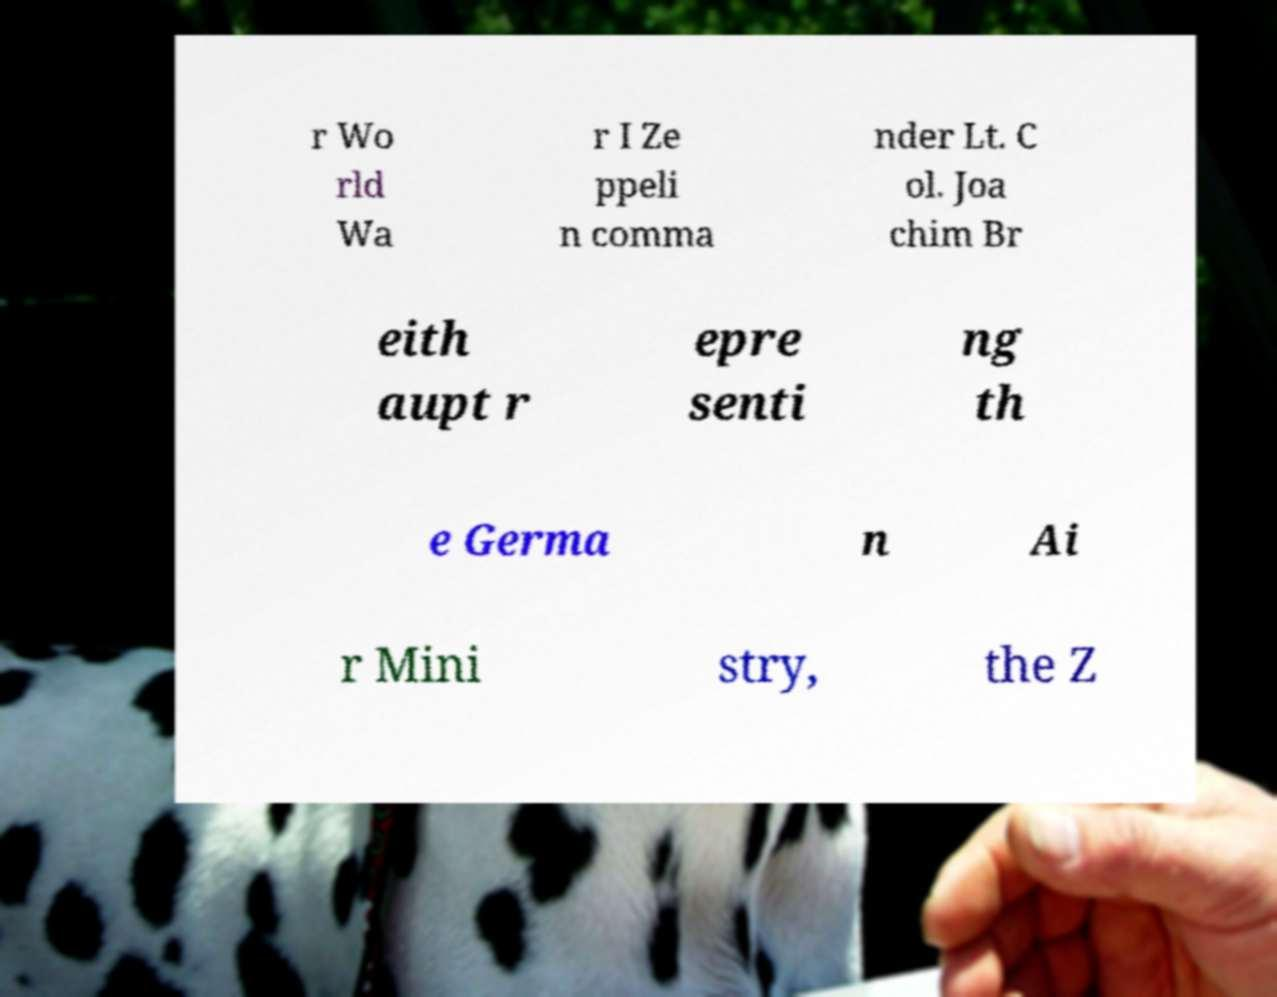Can you accurately transcribe the text from the provided image for me? r Wo rld Wa r I Ze ppeli n comma nder Lt. C ol. Joa chim Br eith aupt r epre senti ng th e Germa n Ai r Mini stry, the Z 